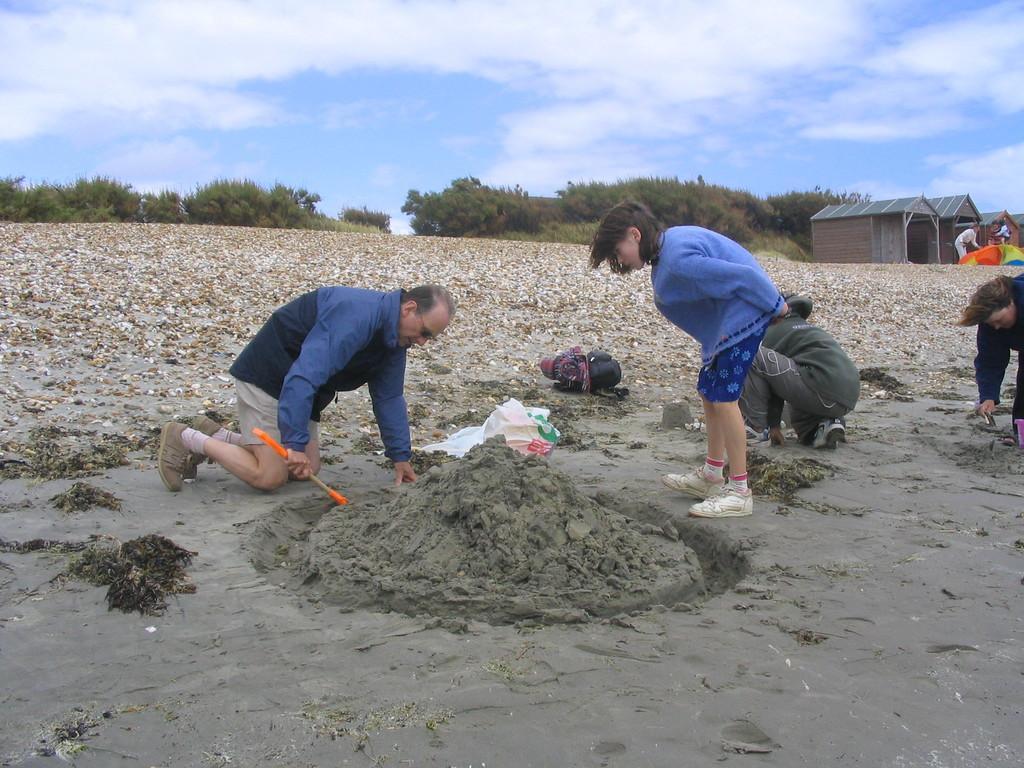How would you summarize this image in a sentence or two? In this picture there is a old man wearing blue color jacket is digging a sand. Beside there is girl standing and looking him. Behind there are many pebbles and trees. On the right side there three shade tent. 